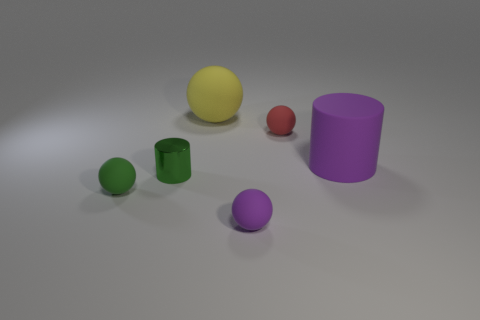What materials do the objects in the image seem to be made of? The objects in the image appear to be made of various materials. The spheres and cylinders exhibit a matte finish suggesting a plastic or rubber composition, while the reflective quality of the green object implies it could be made of glass or a polished metal. 